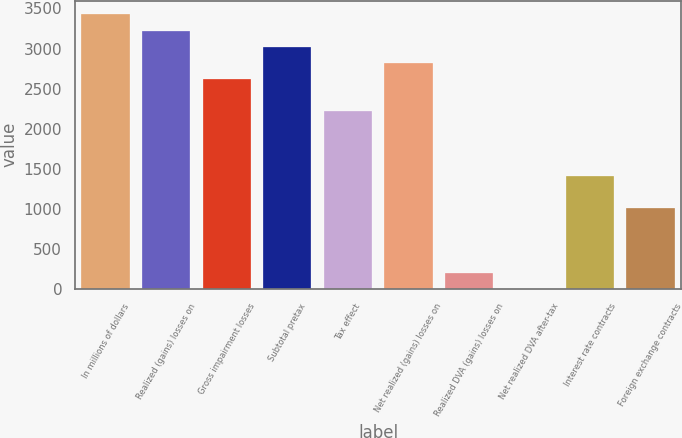<chart> <loc_0><loc_0><loc_500><loc_500><bar_chart><fcel>In millions of dollars<fcel>Realized (gains) losses on<fcel>Gross impairment losses<fcel>Subtotal pretax<fcel>Tax effect<fcel>Net realized (gains) losses on<fcel>Realized DVA (gains) losses on<fcel>Net realized DVA after-tax<fcel>Interest rate contracts<fcel>Foreign exchange contracts<nl><fcel>3425.8<fcel>3224.4<fcel>2620.2<fcel>3023<fcel>2217.4<fcel>2821.6<fcel>203.4<fcel>2<fcel>1411.8<fcel>1009<nl></chart> 